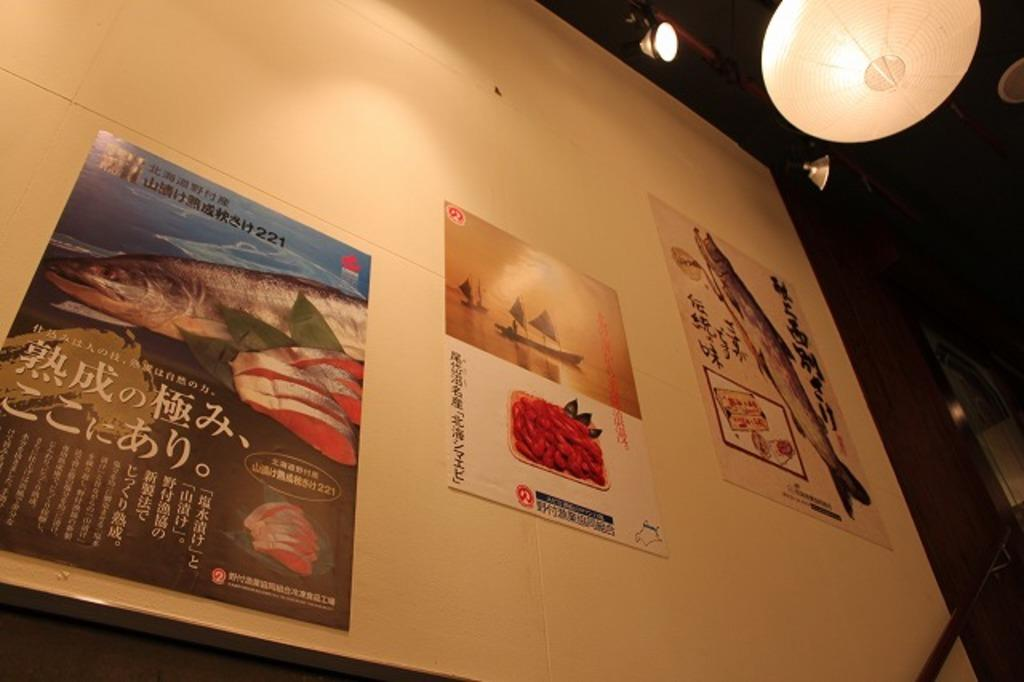What is the main object in the image? There is a whiteboard in the image. What is on the whiteboard? There are pictures on the whiteboard. What can be seen at the top of the image? There are lights at the top of the image. What type of head injury can be seen on the person in the image? There is no person present in the image, and therefore no head injury can be observed. 